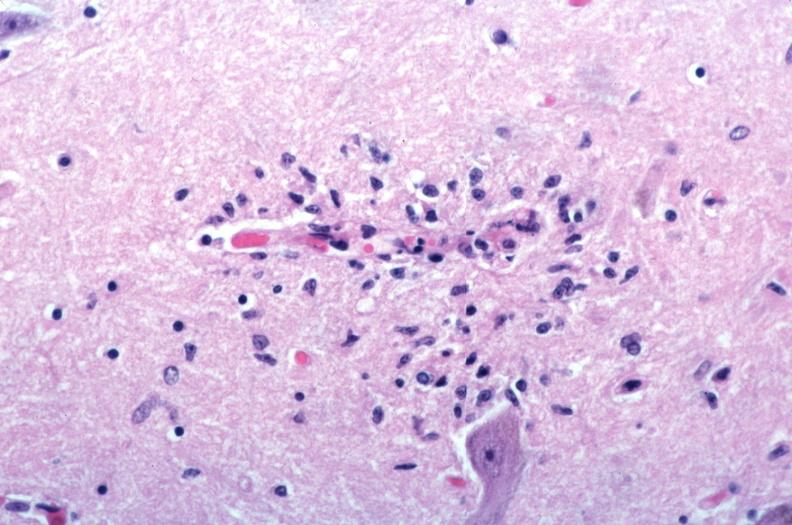what does this image show?
Answer the question using a single word or phrase. Brain 